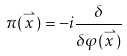Convert formula to latex. <formula><loc_0><loc_0><loc_500><loc_500>\pi ( \stackrel { \rightharpoonup } { x } ) = - i \frac { \delta } { \delta \varphi ( \stackrel { \rightharpoonup } { x } ) }</formula> 